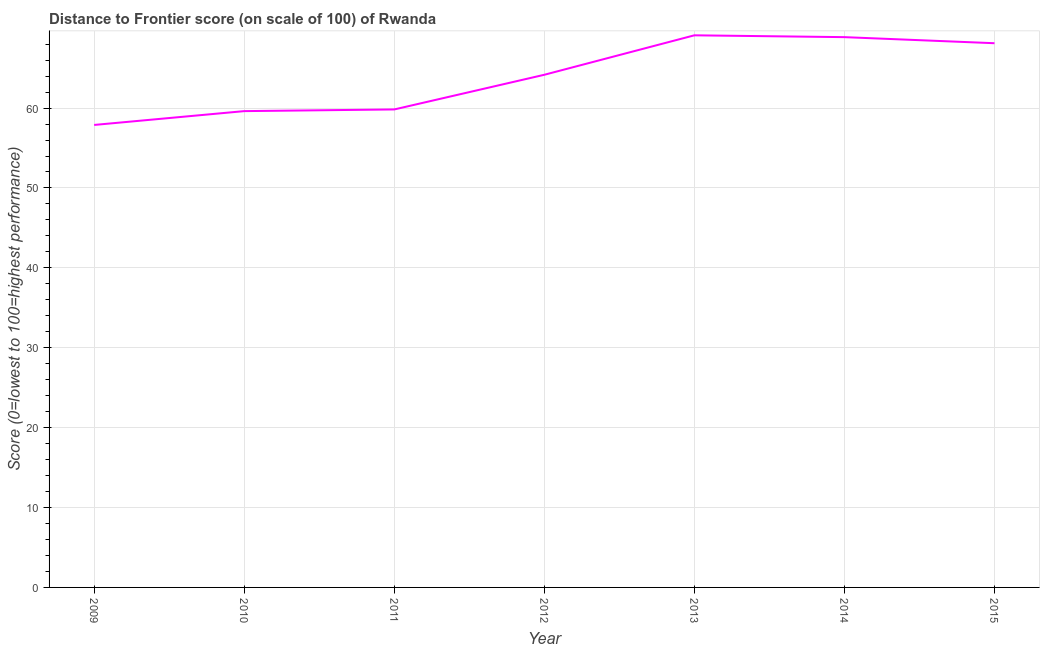What is the distance to frontier score in 2010?
Give a very brief answer. 59.62. Across all years, what is the maximum distance to frontier score?
Offer a very short reply. 69.11. Across all years, what is the minimum distance to frontier score?
Keep it short and to the point. 57.89. What is the sum of the distance to frontier score?
Offer a terse response. 447.62. What is the difference between the distance to frontier score in 2010 and 2015?
Provide a succinct answer. -8.5. What is the average distance to frontier score per year?
Ensure brevity in your answer.  63.95. What is the median distance to frontier score?
Your answer should be compact. 64.17. In how many years, is the distance to frontier score greater than 28 ?
Your response must be concise. 7. What is the ratio of the distance to frontier score in 2009 to that in 2014?
Keep it short and to the point. 0.84. Is the distance to frontier score in 2010 less than that in 2015?
Make the answer very short. Yes. Is the difference between the distance to frontier score in 2012 and 2015 greater than the difference between any two years?
Keep it short and to the point. No. What is the difference between the highest and the second highest distance to frontier score?
Offer a terse response. 0.23. Is the sum of the distance to frontier score in 2014 and 2015 greater than the maximum distance to frontier score across all years?
Your answer should be very brief. Yes. What is the difference between the highest and the lowest distance to frontier score?
Your answer should be very brief. 11.22. How many lines are there?
Keep it short and to the point. 1. How many years are there in the graph?
Keep it short and to the point. 7. What is the difference between two consecutive major ticks on the Y-axis?
Give a very brief answer. 10. Are the values on the major ticks of Y-axis written in scientific E-notation?
Your response must be concise. No. Does the graph contain any zero values?
Your response must be concise. No. What is the title of the graph?
Make the answer very short. Distance to Frontier score (on scale of 100) of Rwanda. What is the label or title of the Y-axis?
Offer a very short reply. Score (0=lowest to 100=highest performance). What is the Score (0=lowest to 100=highest performance) in 2009?
Keep it short and to the point. 57.89. What is the Score (0=lowest to 100=highest performance) of 2010?
Your answer should be very brief. 59.62. What is the Score (0=lowest to 100=highest performance) in 2011?
Provide a succinct answer. 59.83. What is the Score (0=lowest to 100=highest performance) in 2012?
Keep it short and to the point. 64.17. What is the Score (0=lowest to 100=highest performance) of 2013?
Make the answer very short. 69.11. What is the Score (0=lowest to 100=highest performance) of 2014?
Your response must be concise. 68.88. What is the Score (0=lowest to 100=highest performance) of 2015?
Offer a terse response. 68.12. What is the difference between the Score (0=lowest to 100=highest performance) in 2009 and 2010?
Provide a short and direct response. -1.73. What is the difference between the Score (0=lowest to 100=highest performance) in 2009 and 2011?
Keep it short and to the point. -1.94. What is the difference between the Score (0=lowest to 100=highest performance) in 2009 and 2012?
Ensure brevity in your answer.  -6.28. What is the difference between the Score (0=lowest to 100=highest performance) in 2009 and 2013?
Your answer should be very brief. -11.22. What is the difference between the Score (0=lowest to 100=highest performance) in 2009 and 2014?
Provide a succinct answer. -10.99. What is the difference between the Score (0=lowest to 100=highest performance) in 2009 and 2015?
Offer a very short reply. -10.23. What is the difference between the Score (0=lowest to 100=highest performance) in 2010 and 2011?
Make the answer very short. -0.21. What is the difference between the Score (0=lowest to 100=highest performance) in 2010 and 2012?
Give a very brief answer. -4.55. What is the difference between the Score (0=lowest to 100=highest performance) in 2010 and 2013?
Your response must be concise. -9.49. What is the difference between the Score (0=lowest to 100=highest performance) in 2010 and 2014?
Give a very brief answer. -9.26. What is the difference between the Score (0=lowest to 100=highest performance) in 2010 and 2015?
Offer a terse response. -8.5. What is the difference between the Score (0=lowest to 100=highest performance) in 2011 and 2012?
Your answer should be compact. -4.34. What is the difference between the Score (0=lowest to 100=highest performance) in 2011 and 2013?
Your response must be concise. -9.28. What is the difference between the Score (0=lowest to 100=highest performance) in 2011 and 2014?
Provide a short and direct response. -9.05. What is the difference between the Score (0=lowest to 100=highest performance) in 2011 and 2015?
Your answer should be compact. -8.29. What is the difference between the Score (0=lowest to 100=highest performance) in 2012 and 2013?
Your response must be concise. -4.94. What is the difference between the Score (0=lowest to 100=highest performance) in 2012 and 2014?
Your response must be concise. -4.71. What is the difference between the Score (0=lowest to 100=highest performance) in 2012 and 2015?
Offer a very short reply. -3.95. What is the difference between the Score (0=lowest to 100=highest performance) in 2013 and 2014?
Your answer should be compact. 0.23. What is the difference between the Score (0=lowest to 100=highest performance) in 2013 and 2015?
Offer a very short reply. 0.99. What is the difference between the Score (0=lowest to 100=highest performance) in 2014 and 2015?
Offer a very short reply. 0.76. What is the ratio of the Score (0=lowest to 100=highest performance) in 2009 to that in 2012?
Provide a short and direct response. 0.9. What is the ratio of the Score (0=lowest to 100=highest performance) in 2009 to that in 2013?
Give a very brief answer. 0.84. What is the ratio of the Score (0=lowest to 100=highest performance) in 2009 to that in 2014?
Offer a very short reply. 0.84. What is the ratio of the Score (0=lowest to 100=highest performance) in 2010 to that in 2012?
Give a very brief answer. 0.93. What is the ratio of the Score (0=lowest to 100=highest performance) in 2010 to that in 2013?
Give a very brief answer. 0.86. What is the ratio of the Score (0=lowest to 100=highest performance) in 2010 to that in 2014?
Offer a very short reply. 0.87. What is the ratio of the Score (0=lowest to 100=highest performance) in 2010 to that in 2015?
Give a very brief answer. 0.88. What is the ratio of the Score (0=lowest to 100=highest performance) in 2011 to that in 2012?
Provide a short and direct response. 0.93. What is the ratio of the Score (0=lowest to 100=highest performance) in 2011 to that in 2013?
Keep it short and to the point. 0.87. What is the ratio of the Score (0=lowest to 100=highest performance) in 2011 to that in 2014?
Your answer should be very brief. 0.87. What is the ratio of the Score (0=lowest to 100=highest performance) in 2011 to that in 2015?
Give a very brief answer. 0.88. What is the ratio of the Score (0=lowest to 100=highest performance) in 2012 to that in 2013?
Make the answer very short. 0.93. What is the ratio of the Score (0=lowest to 100=highest performance) in 2012 to that in 2014?
Give a very brief answer. 0.93. What is the ratio of the Score (0=lowest to 100=highest performance) in 2012 to that in 2015?
Offer a very short reply. 0.94. What is the ratio of the Score (0=lowest to 100=highest performance) in 2013 to that in 2014?
Make the answer very short. 1. What is the ratio of the Score (0=lowest to 100=highest performance) in 2014 to that in 2015?
Provide a succinct answer. 1.01. 